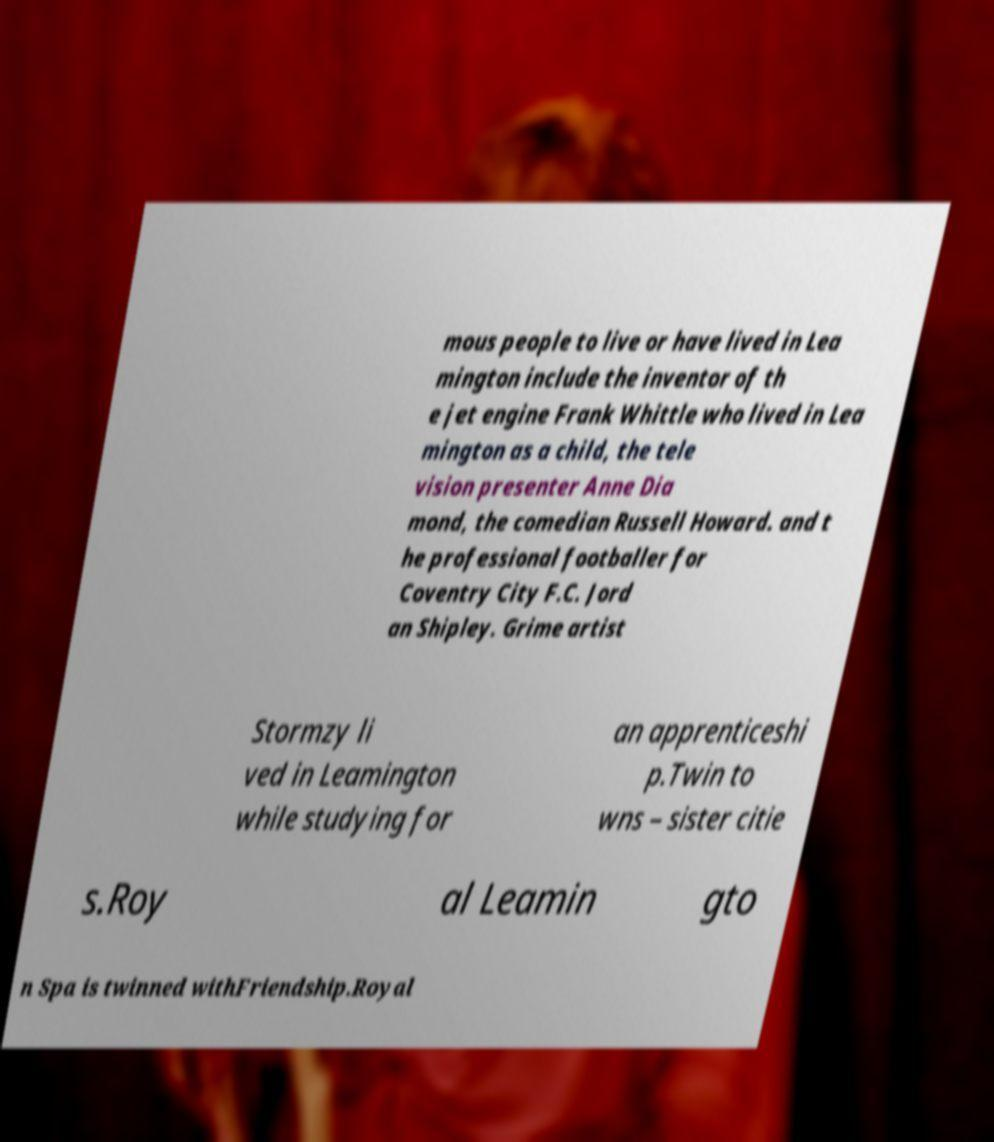I need the written content from this picture converted into text. Can you do that? mous people to live or have lived in Lea mington include the inventor of th e jet engine Frank Whittle who lived in Lea mington as a child, the tele vision presenter Anne Dia mond, the comedian Russell Howard. and t he professional footballer for Coventry City F.C. Jord an Shipley. Grime artist Stormzy li ved in Leamington while studying for an apprenticeshi p.Twin to wns – sister citie s.Roy al Leamin gto n Spa is twinned withFriendship.Royal 